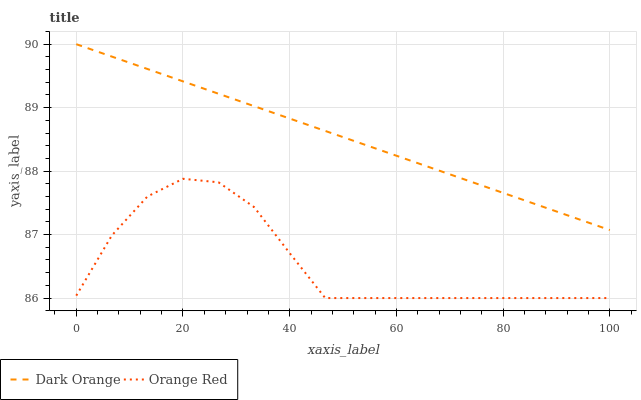Does Orange Red have the minimum area under the curve?
Answer yes or no. Yes. Does Dark Orange have the maximum area under the curve?
Answer yes or no. Yes. Does Orange Red have the maximum area under the curve?
Answer yes or no. No. Is Dark Orange the smoothest?
Answer yes or no. Yes. Is Orange Red the roughest?
Answer yes or no. Yes. Is Orange Red the smoothest?
Answer yes or no. No. Does Dark Orange have the highest value?
Answer yes or no. Yes. Does Orange Red have the highest value?
Answer yes or no. No. Is Orange Red less than Dark Orange?
Answer yes or no. Yes. Is Dark Orange greater than Orange Red?
Answer yes or no. Yes. Does Orange Red intersect Dark Orange?
Answer yes or no. No. 